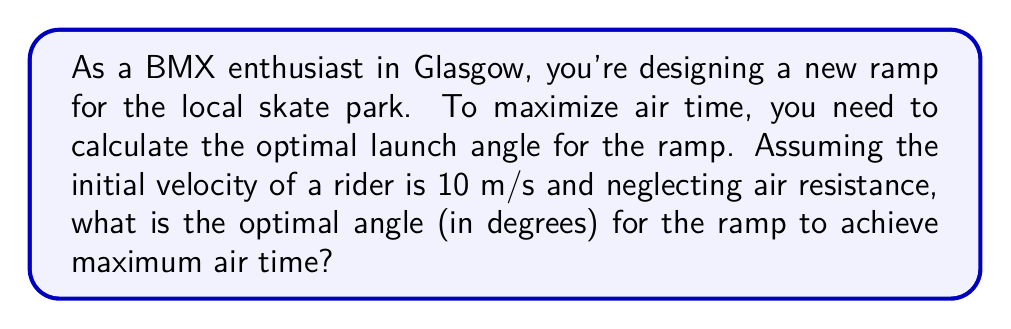Give your solution to this math problem. To solve this problem, we need to use concepts from projectile motion. The time of flight for a projectile launched at an angle $\theta$ with initial velocity $v_0$ is given by:

$$t = \frac{2v_0 \sin\theta}{g}$$

Where $g$ is the acceleration due to gravity (9.8 m/s²).

To maximize air time, we need to find the angle $\theta$ that maximizes this equation. The sine function reaches its maximum value at 90°, but due to the nature of projectile motion, the optimal angle for maximum air time is always 45°.

We can prove this mathematically:

1. The derivative of $\sin\theta$ with respect to $\theta$ is $\cos\theta$.
2. Setting this derivative to zero:
   $$\cos\theta = 0$$
3. Solving this equation gives us $\theta = 90°$.
4. However, at 90°, the horizontal component of velocity would be zero, resulting in no forward motion.
5. The next best angle that maximizes both vertical and horizontal components is 45°.

At 45°, $\sin\theta = \cos\theta = \frac{1}{\sqrt{2}} \approx 0.707$

This angle ensures the optimal balance between vertical and horizontal velocity components, resulting in maximum air time for the BMX rider.

[asy]
import geometry;

size(200);
draw((-1,0)--(5,0),arrow=Arrow(TeXHead));
draw((0,-1)--(0,3),arrow=Arrow(TeXHead));
draw((0,0)--(3,3),arrow=Arrow(TeXHead));
label("45°",(0.5,0.5),NE);
label("$v_0$",(1.5,1.5),NE);
label("$x$",(5,0),S);
label("$y$",(0,3),W);
[/asy]
Answer: The optimal angle for the BMX ramp to maximize air time is 45°. 